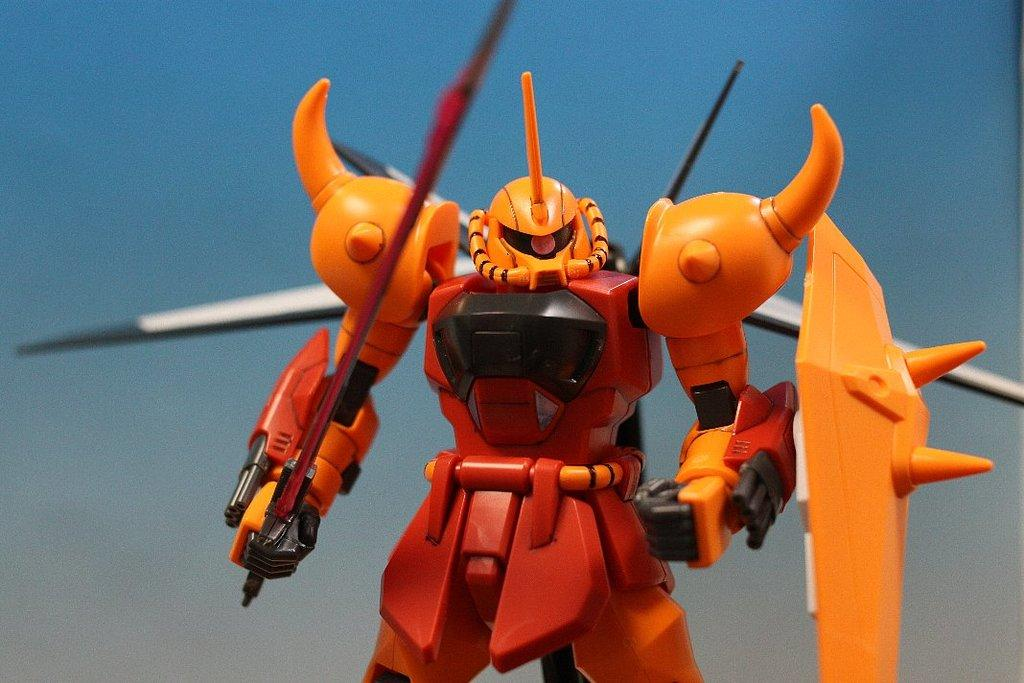What is the main subject of the image? There is a toy robot in the image. What color is the background of the image? The background of the image is blue. How does the toy robot contribute to pollution in the image? The image does not show any pollution, and the toy robot is not contributing to any pollution. What type of bears can be seen interacting with the toy robot in the image? There are no bears present in the image; it only features a toy robot. 